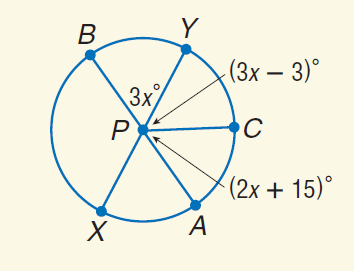Question: Find m \widehat B X.
Choices:
A. 21
B. 45
C. 63
D. 117
Answer with the letter. Answer: D Question: Find m \widehat Y C.
Choices:
A. 21
B. 60
C. 75
D. 180
Answer with the letter. Answer: B Question: Find m \widehat B C A.
Choices:
A. 30
B. 45
C. 55
D. 180
Answer with the letter. Answer: D 